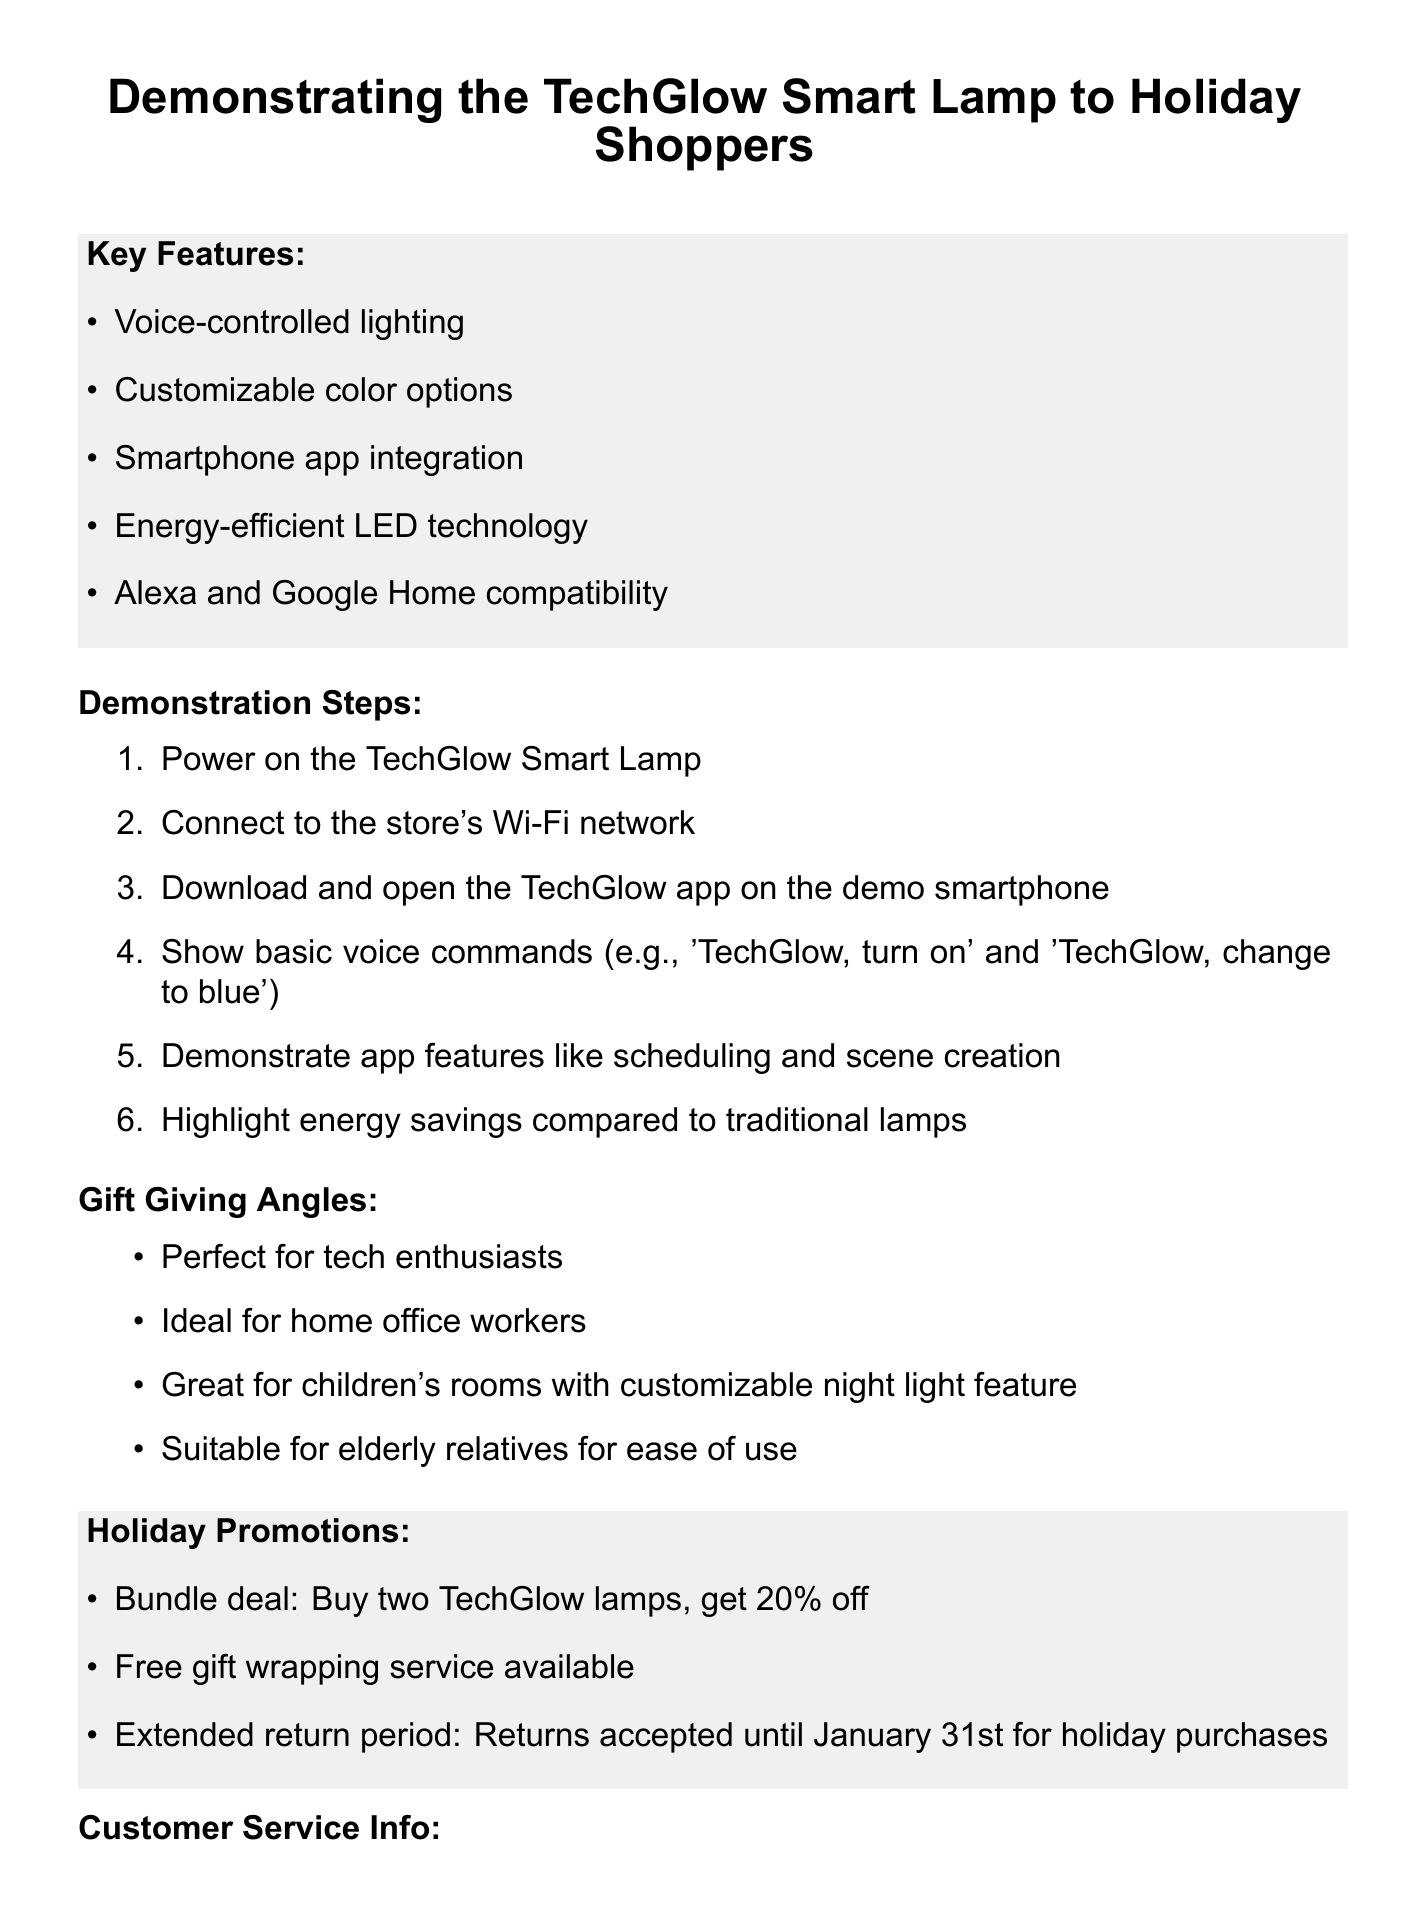What is the product name? The product name is explicitly mentioned in the memo.
Answer: TechGlow Smart Lamp Who is the startup behind the product? The memo states the name of the startup that created the product.
Answer: LuminaTech What is the warranty period for the product? The document specifies the warranty period for the TechGlow Smart Lamp.
Answer: 2-year limited warranty What holiday promotion offers a discount? This promotion is specifically mentioned in the holiday promotions section of the memo.
Answer: Buy two TechGlow lamps, get 20% off What feature helps reduce energy bills? This feature is mentioned in the key features section that addresses customer pain points.
Answer: Energy-efficient LED technology How is the setup process described compared to LIFX bulbs? This information is related to competitive advantages stated in the memo.
Answer: Easier setup process What should staff do before activating voice commands? This guideline is listed in the staff guidelines section of the document.
Answer: Ask permission What is highlighted as beneficial for elderly relatives? The document provides gift-giving angles that are relevant for this group.
Answer: Ease of use What is the support hotline number? The memo contains specific customer service information, including this hotline number.
Answer: 1-800-TECHGLOW 